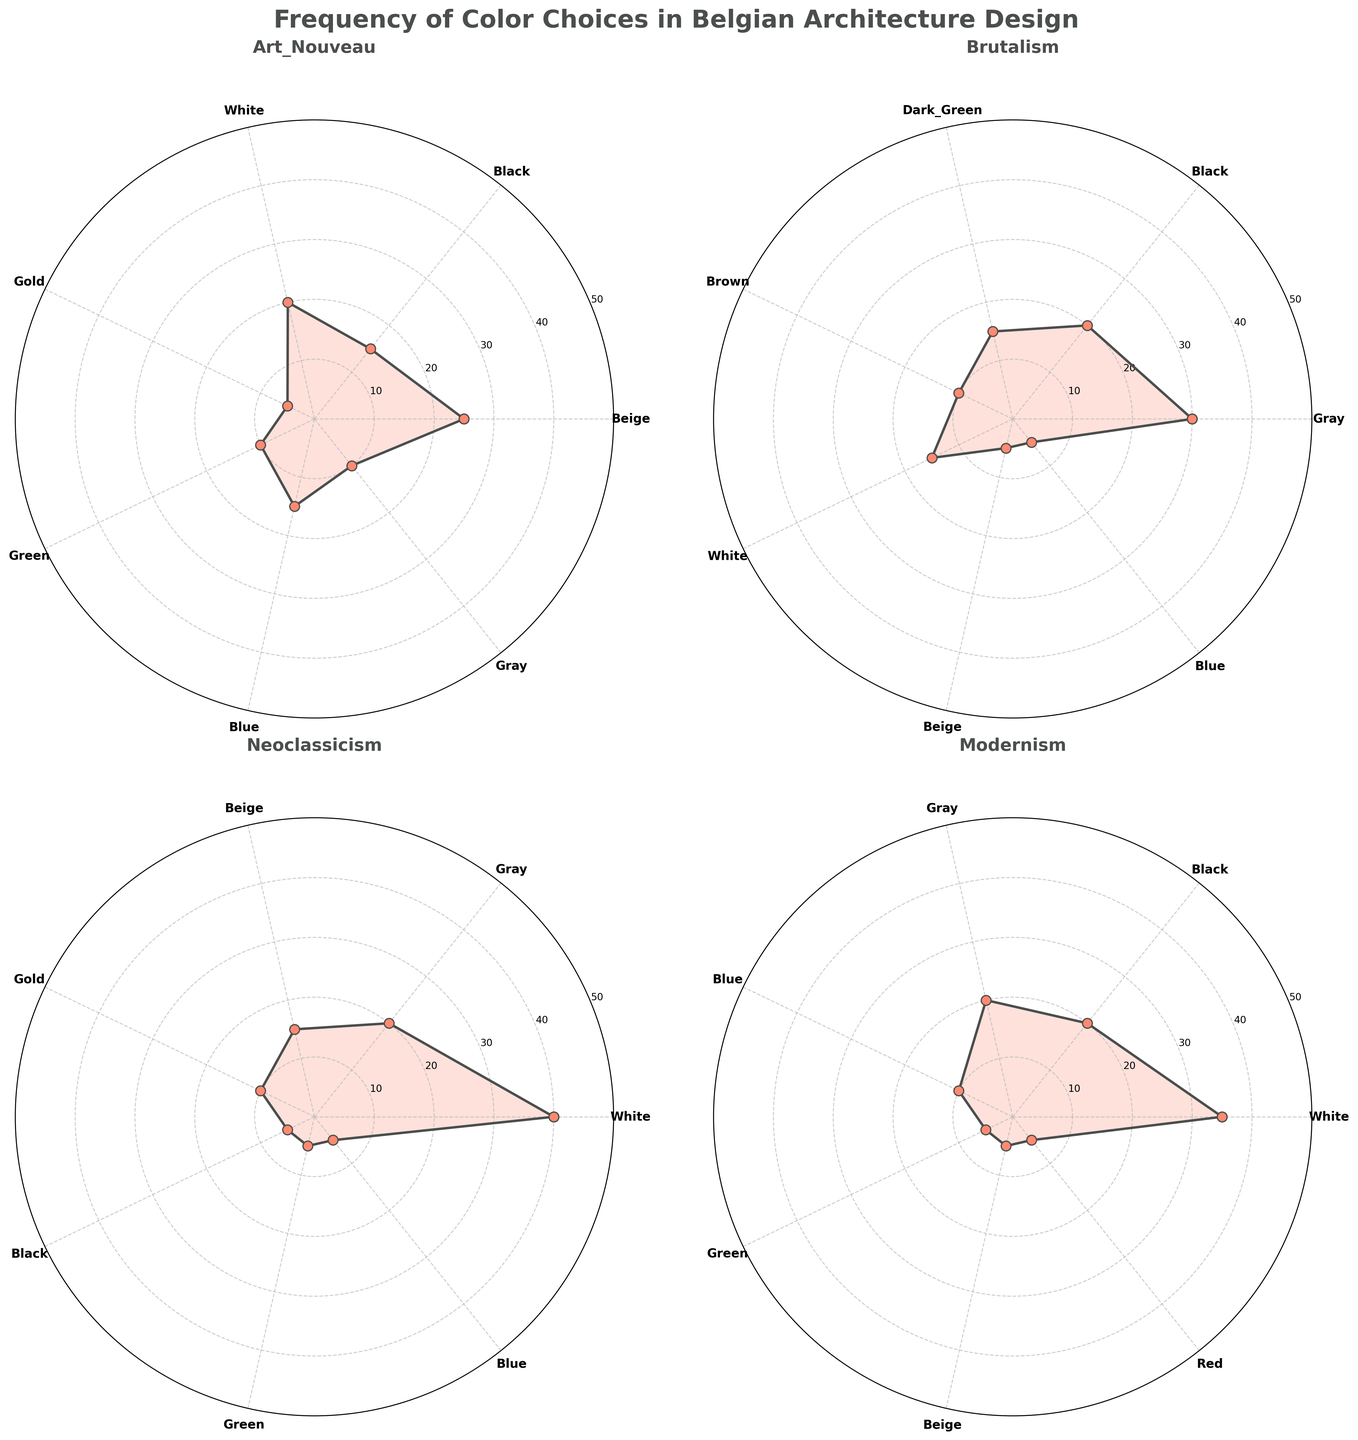Which architectural style uses gray the most frequently? By examining the radar chart for each style, we see that Brutalism has the highest percentage for gray at 30%.
Answer: Brutalism How often is black used in Modernism compared to Art Nouveau? In the radar charts, Modernism has black at 20%, and Art Nouveau has black at 15%. Thus, black is used 5% more in Modernism than in Art Nouveau.
Answer: 5% more in Modernism What is the total percentage of white across all architectural styles? Adding white percentages: Art Nouveau (20%) + Brutalism (15%) + Neoclassicism (40%) + Modernism (35%) = 110%.
Answer: 110% Which color is most frequently used in Art Nouveau? From the Art Nouveau radar chart, beige has the highest percentage at 25%.
Answer: Beige Is blue used more in Neoclassicism or Modernism? By checking the radar charts, both Neoclassicism and Modernism each have a blue percentage of 5% and 10% respectively.
Answer: Modernism What is the median percentage of colors in Brutalism? The percentages for Brutalism are 30, 20, 15, 10, 15, 5, 5. Sorting these gives 5, 5, 10, 15, 15, 20, 30. The median is the middle value, which is 15.
Answer: 15 Which architectural style features the widest range of color usage? The range is determined by the difference between the maximum and minimum percentages. Calculating this for each style gives: 
Art Nouveau: 25-5 = 20,
Brutalism: 30-5 = 25,
Neoclassicism: 40-5 = 35,
Modernism: 35-5 = 30.
Thus, Neoclassicism has the widest range.
Answer: Neoclassicism What is the combined percentage for beige in Brutalism and Neoclassicism? Adding the beige percentages: Brutalism (5%) + Neoclassicism (15%) = 20%.
Answer: 20% Which radar chart shows the smallest total area for all colors? Summing the percentages for all colors: 
Art Nouveau: 25+15+20+5+10+15+10=100,
Brutalism: 30+20+15+10+15+5+5=100,
Neoclassicism: 40+20+15+10+5+5+5=100,
Modernism: 35+20+20+10+5+5+5=100. 
All areas sum to 100, thus no chart has a smaller total area.
Answer: All equal 